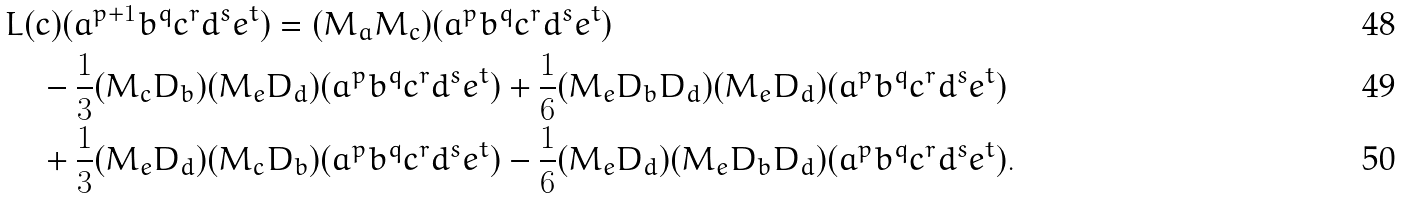<formula> <loc_0><loc_0><loc_500><loc_500>& L ( c ) ( a ^ { p + 1 } b ^ { q } c ^ { r } d ^ { s } e ^ { t } ) = ( M _ { a } M _ { c } ) ( a ^ { p } b ^ { q } c ^ { r } d ^ { s } e ^ { t } ) \\ & \quad - \frac { 1 } { 3 } ( M _ { c } D _ { b } ) ( M _ { e } D _ { d } ) ( a ^ { p } b ^ { q } c ^ { r } d ^ { s } e ^ { t } ) + \frac { 1 } { 6 } ( M _ { e } D _ { b } D _ { d } ) ( M _ { e } D _ { d } ) ( a ^ { p } b ^ { q } c ^ { r } d ^ { s } e ^ { t } ) \\ & \quad + \frac { 1 } { 3 } ( M _ { e } D _ { d } ) ( M _ { c } D _ { b } ) ( a ^ { p } b ^ { q } c ^ { r } d ^ { s } e ^ { t } ) - \frac { 1 } { 6 } ( M _ { e } D _ { d } ) ( M _ { e } D _ { b } D _ { d } ) ( a ^ { p } b ^ { q } c ^ { r } d ^ { s } e ^ { t } ) .</formula> 